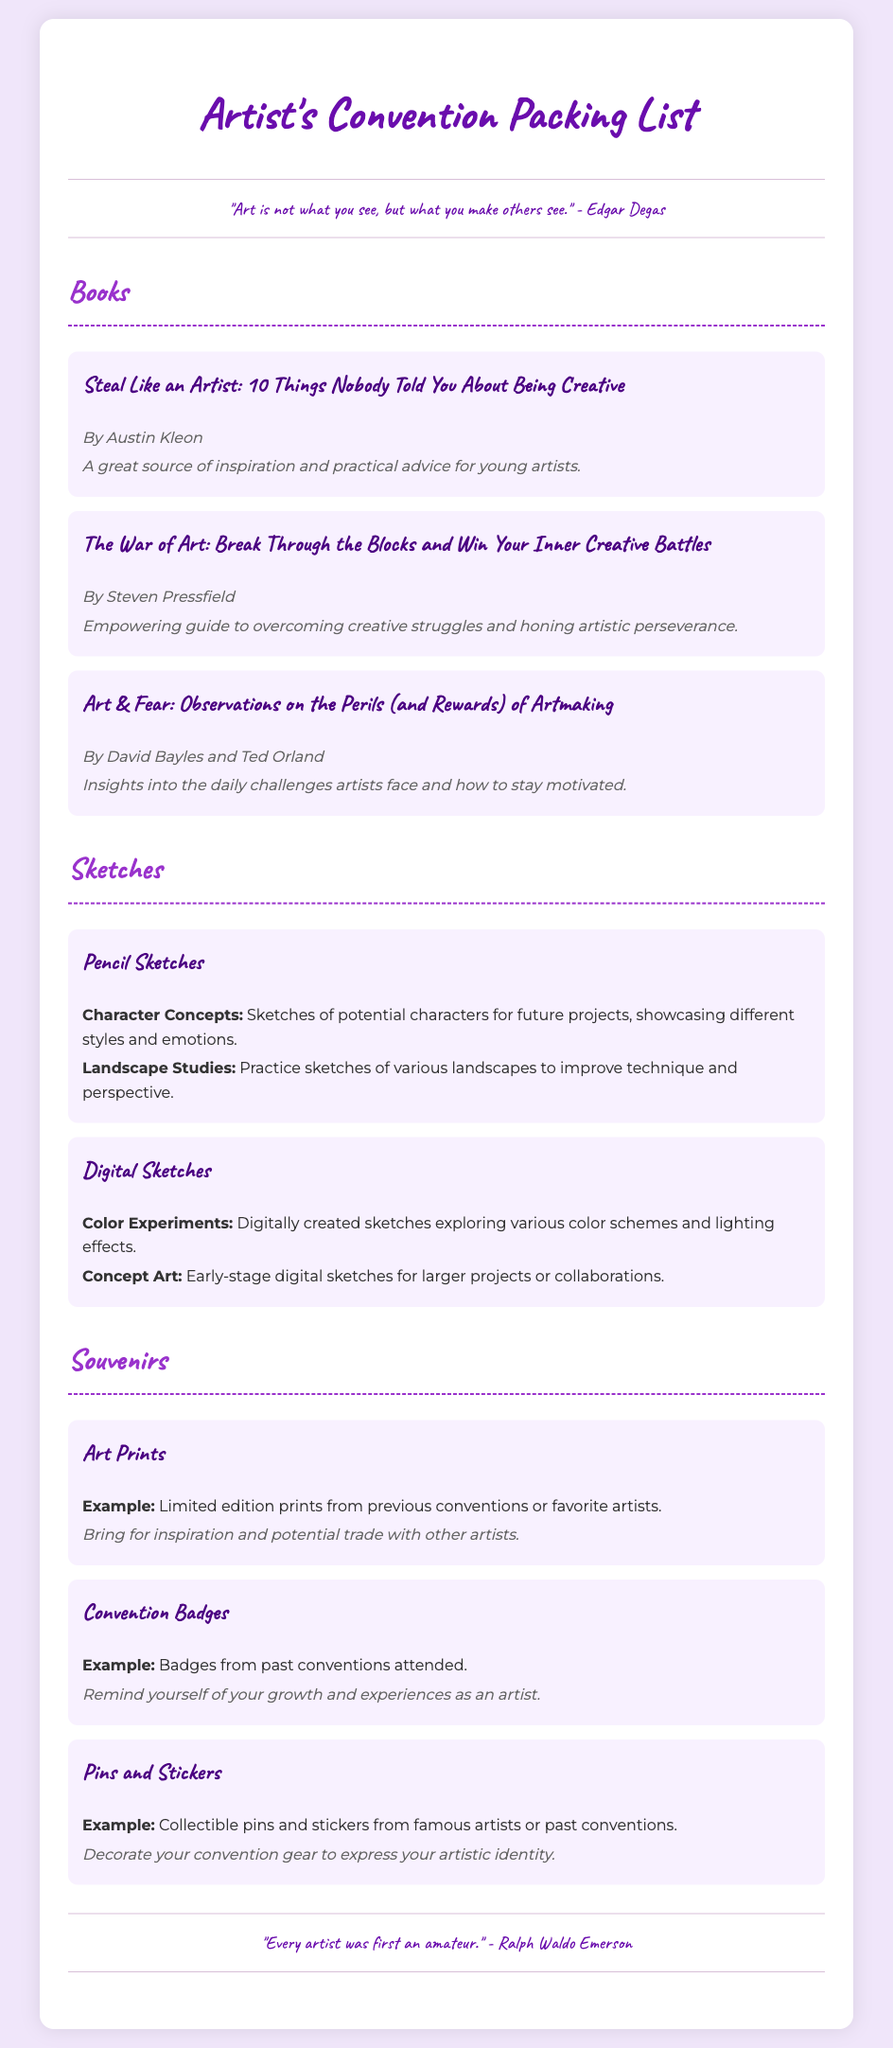What is the first book listed in the packing list? The first book is a specific title mentioned under the "Books" section of the packing list.
Answer: Steal Like an Artist: 10 Things Nobody Told You About Being Creative Who is the author of "The War of Art"? The author of "The War of Art" is provided along with the title in the document.
Answer: Steven Pressfield What type of sketches are included in the packing list? The sketch types are mentioned in categories under the "Sketches" section.
Answer: Pencil Sketches and Digital Sketches How many art prints are listed as souvenirs? The number of souvenirs is specified by the items under the "Souvenirs" section of the packing list.
Answer: One type (Art Prints) is listed, but it includes a general example What does the quote by Edgar Degas say? The quote is provided in the document, highlighting a prominent thought about art.
Answer: "Art is not what you see, but what you make others see." Which category includes sketches of character concepts? The category can be identified based on the description of sketches in the "Sketches" section.
Answer: Pencil Sketches What is the purpose of bringing convention badges? The purpose is explained in the notes associated with one of the souvenir types.
Answer: Remind yourself of your growth and experiences as an artist 